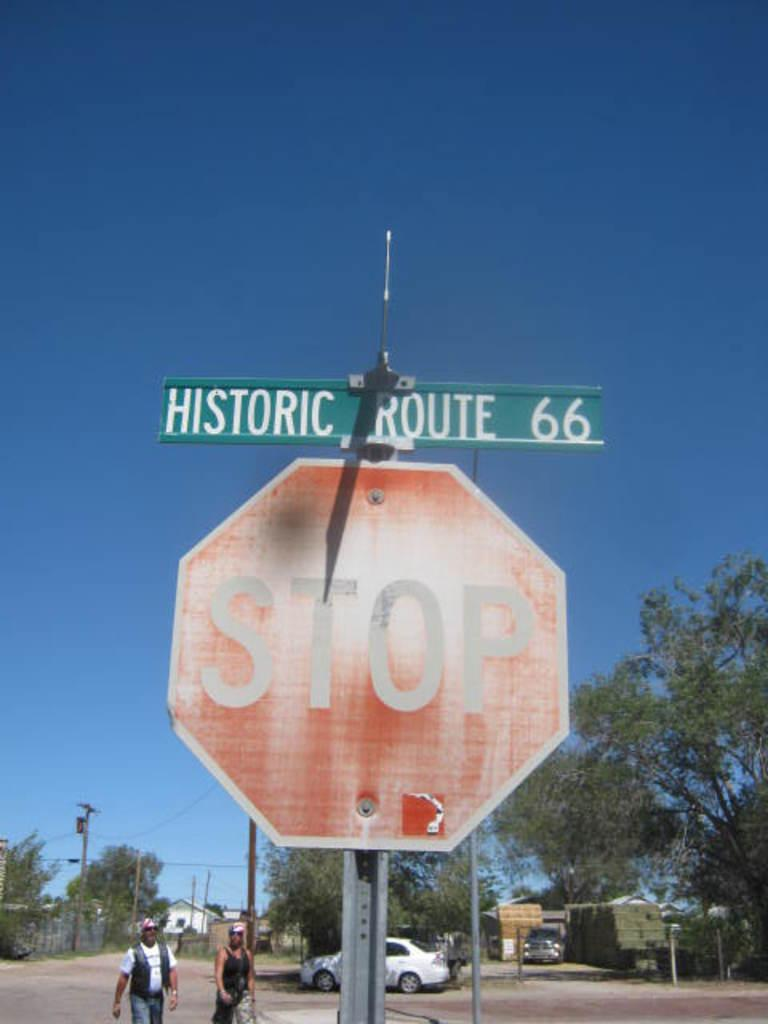<image>
Provide a brief description of the given image. A stop sign below a Historic Route 66 sign. 